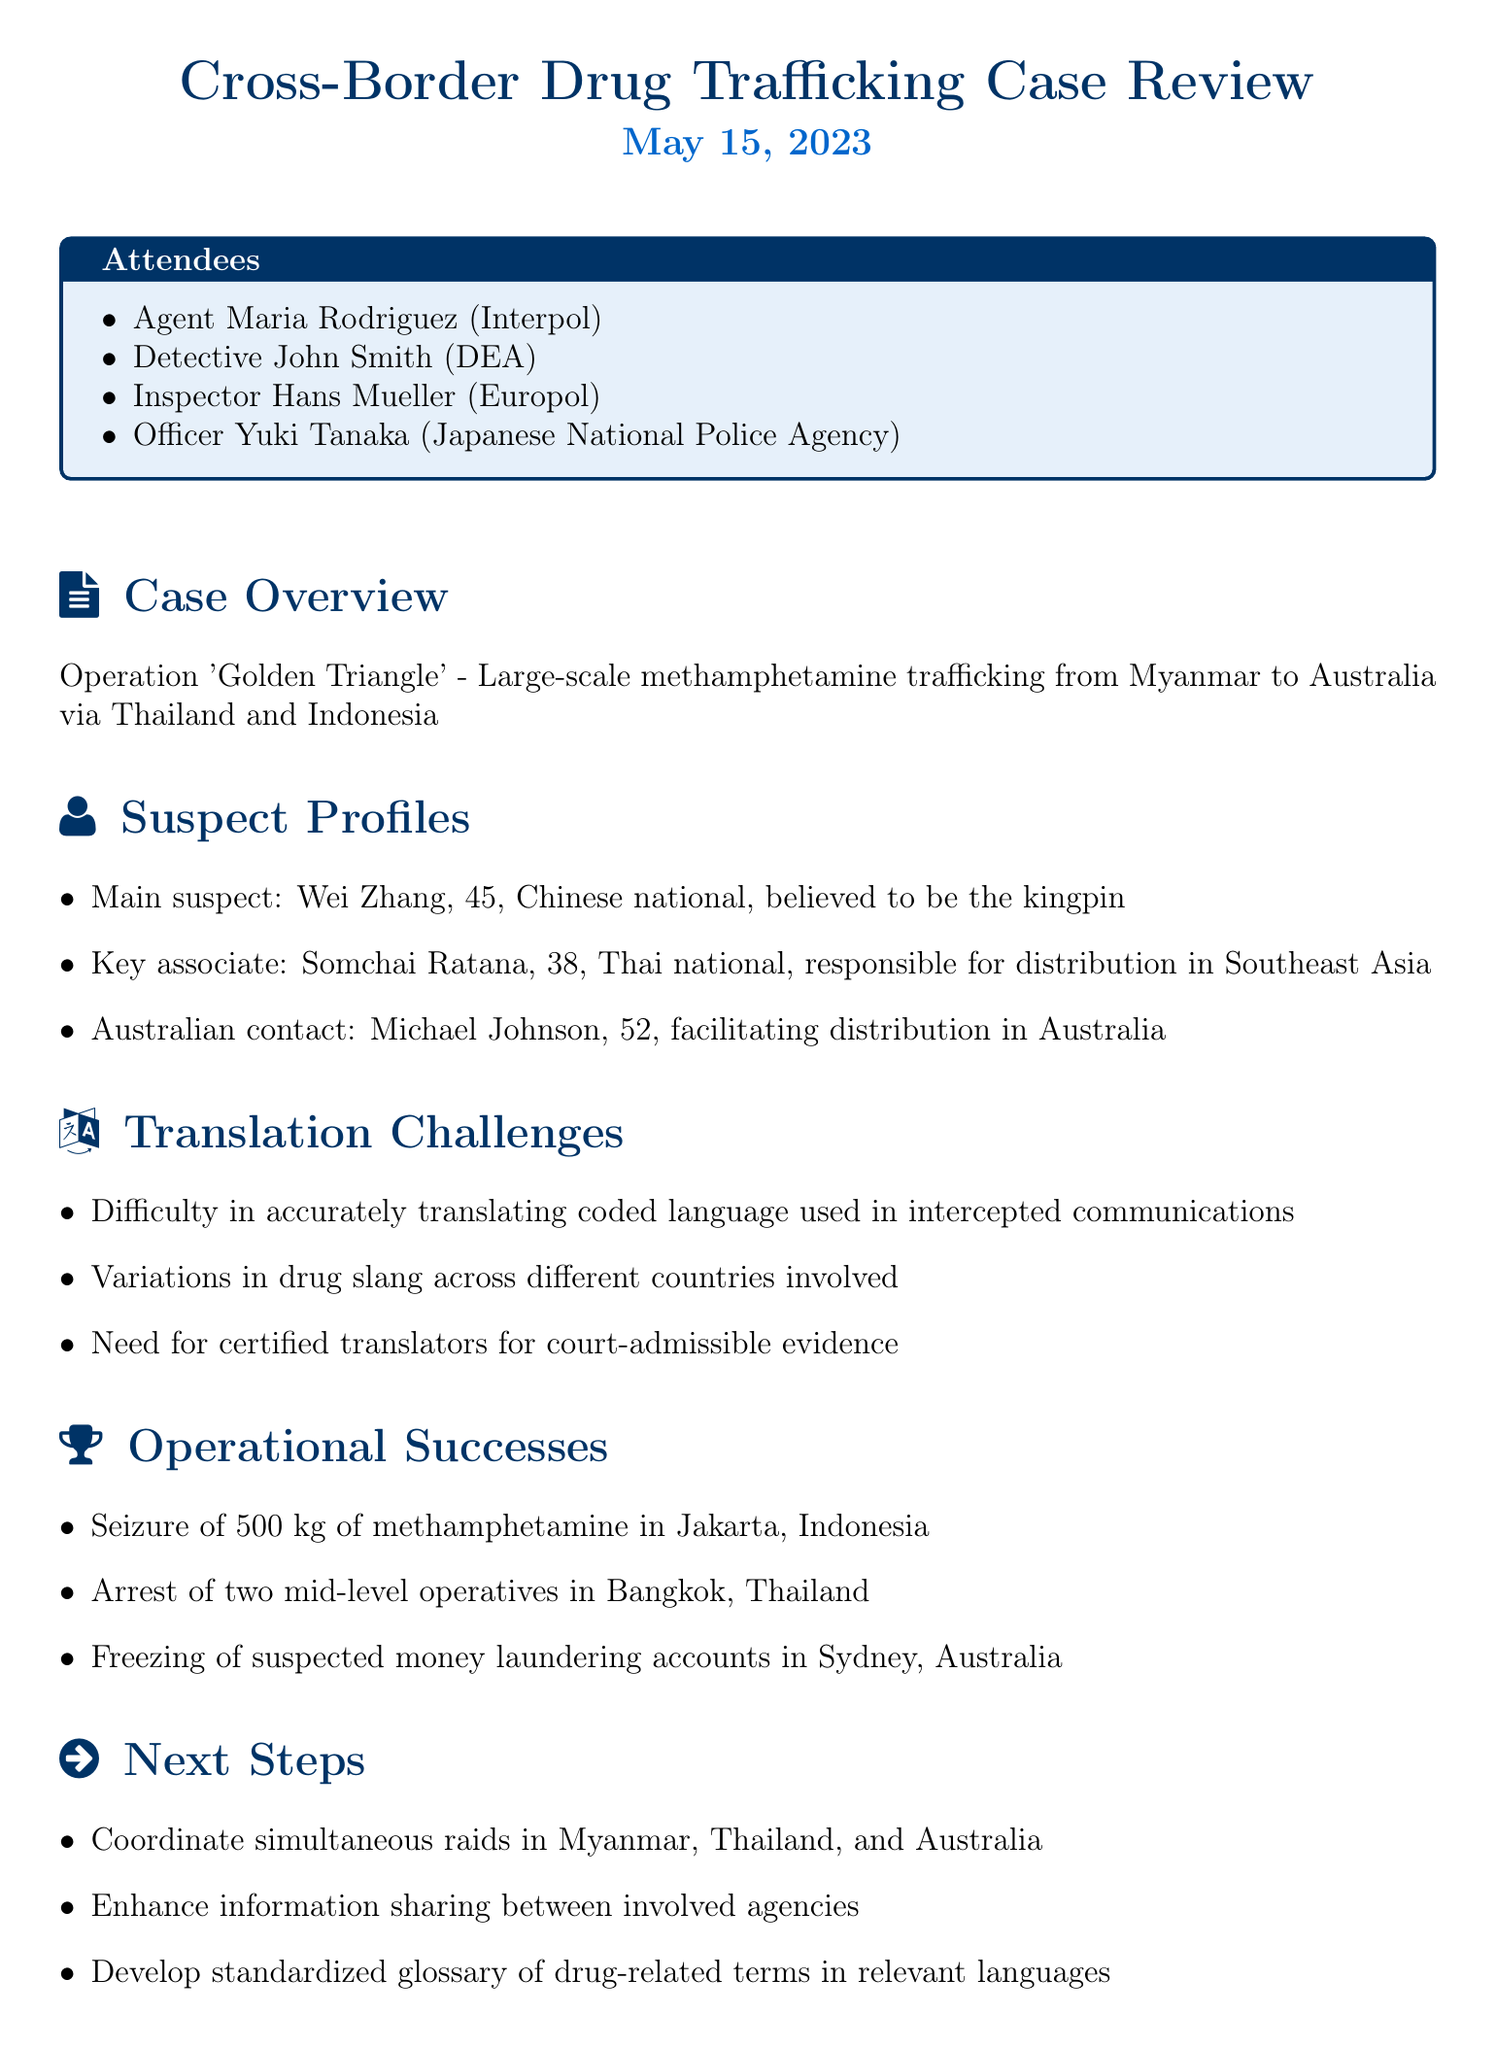What is the operation's name? The document mentions the operation as "Operation 'Golden Triangle'."
Answer: Operation 'Golden Triangle' Who is the main suspect? The main suspect listed in the document is Wei Zhang.
Answer: Wei Zhang How many kilograms of methamphetamine were seized? The document states that 500 kg of methamphetamine was seized.
Answer: 500 kg Which country is the key associate Somchai Ratana from? Somchai Ratana is identified as a Thai national in the document.
Answer: Thailand What is one of the translation challenges mentioned? One of the translation challenges noted is the difficulty in accurately translating coded language.
Answer: Difficulty in accurately translating coded language What is the age of Michael Johnson? The document provides that Michael Johnson is 52 years old.
Answer: 52 What is one of the operational successes? The document lists the freezing of suspected money laundering accounts in Sydney as one success.
Answer: Freezing of suspected money laundering accounts in Sydney What is the next step regarding raids? The document suggests coordinating simultaneous raids in Myanmar, Thailand, and Australia as a next step.
Answer: Coordinate simultaneous raids in Myanmar, Thailand, and Australia Who conducted the meeting? The attendees' names indicate that it was conducted by representatives of various organizations, including Interpol and DEA.
Answer: Agent Maria Rodriguez (Interpol), Detective John Smith (DEA), Inspector Hans Mueller (Europol), Officer Yuki Tanaka (Japanese National Police Agency) 